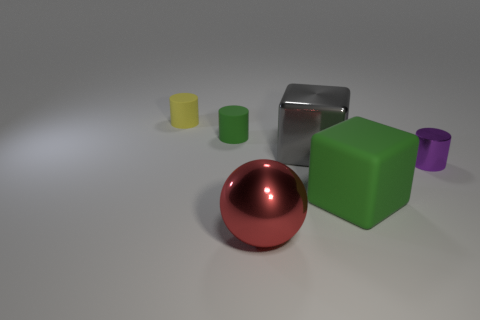Are there any patterns or symmetry in the composition of this image? The composition of the image doesn't exhibit a strict pattern or symmetry. However, there is a sense of balance with the red sphere positioned centrally and other objects grouped around it. The arrangement and varying heights of the objects create a casual yet harmonious scene without formal symmetry. 